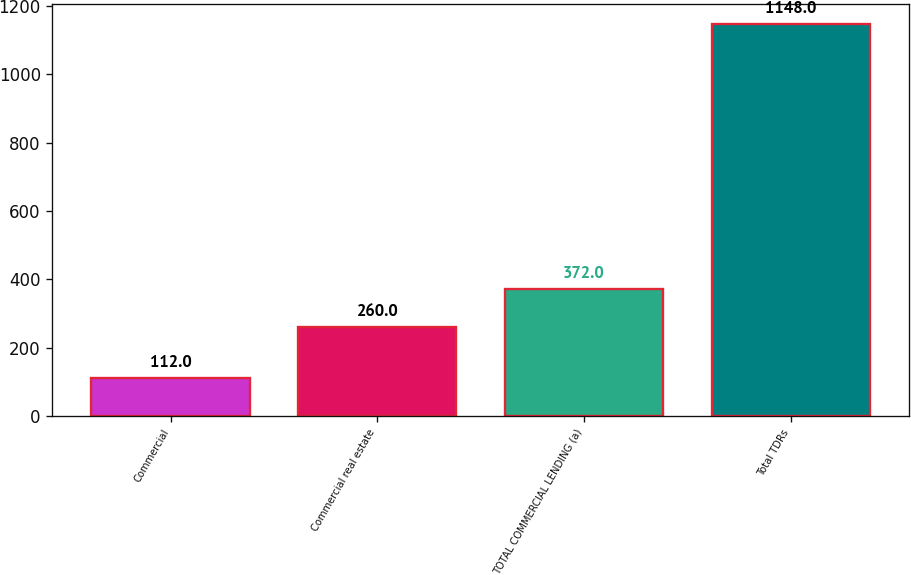<chart> <loc_0><loc_0><loc_500><loc_500><bar_chart><fcel>Commercial<fcel>Commercial real estate<fcel>TOTAL COMMERCIAL LENDING (a)<fcel>Total TDRs<nl><fcel>112<fcel>260<fcel>372<fcel>1148<nl></chart> 